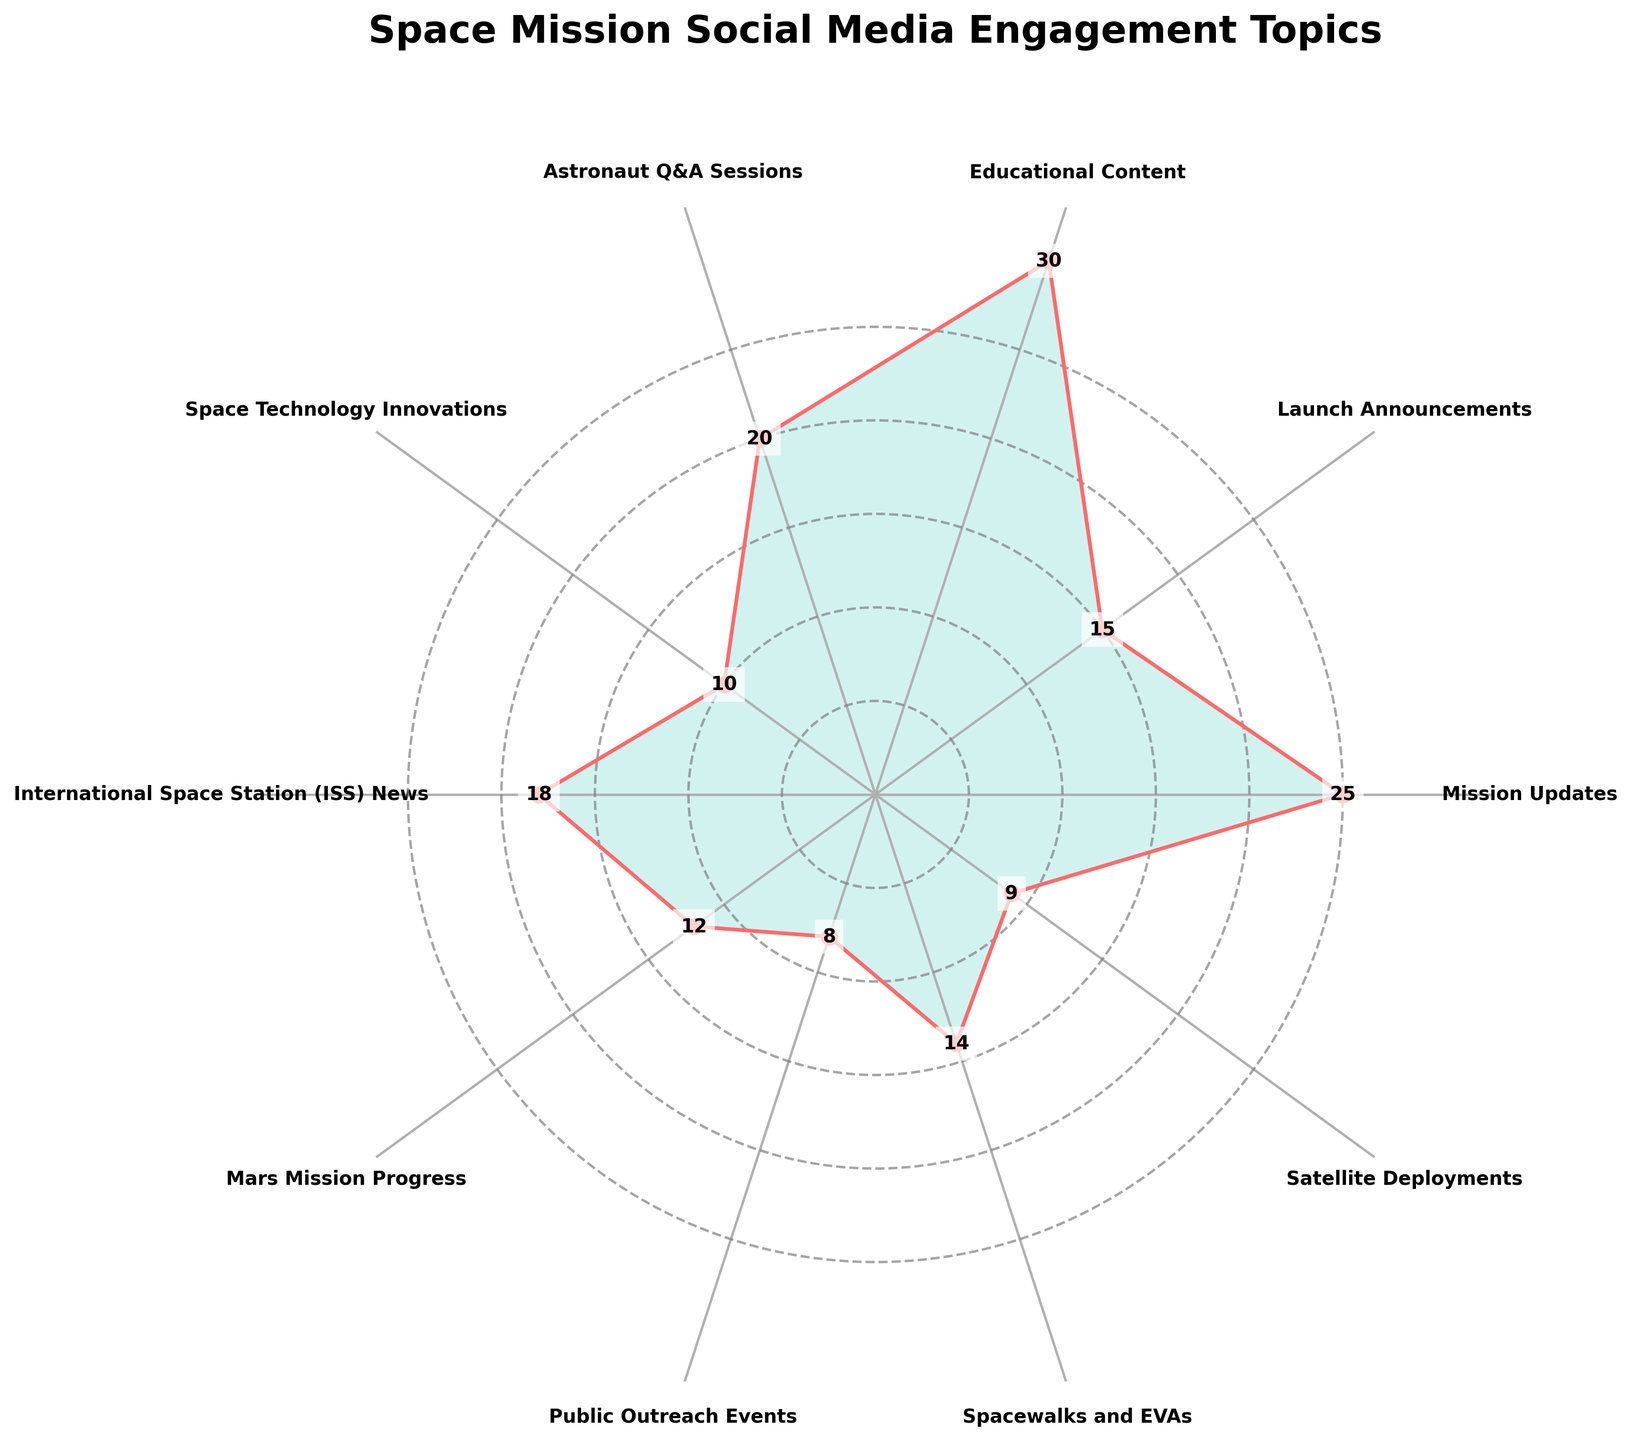Which topic has the highest frequency of social media engagement? By looking at the plot, the topic with the largest value indicated by the highest point on the chart is the one with the highest frequency. This is Educational Content with a frequency of 30.
Answer: Educational Content Which topic has the lowest frequency of social media engagement? Observing the plot, the topic with the smallest value indicated by the lowest point on the chart is the one with the lowest frequency. This is Public Outreach Events with a frequency of 8.
Answer: Public Outreach Events How many topics have a frequency higher than 20? Count the number of topics whose frequencies are positioned above the 20-mark on the radial axis. The topics are Mission Updates (25), Educational Content (30). Therefore, there are 2 topics.
Answer: 2 What is the average frequency of engagement across all topics? Sum all frequencies: 25 + 15 + 30 + 20 + 10 + 18 + 12 + 8 + 14 + 9 = 161. There are 10 topics, so the average frequency is 161 / 10 = 16.1.
Answer: 16.1 Which topic has a frequency closest to 15? Looking at the radial alignments around 15, Launch Announcements with a frequency of 15 is the closest.
Answer: Launch Announcements What is the total frequency for Mission Updates and Spacewalks and EVAs combined? Add the frequencies of the two topics: Mission Updates (25) + Spacewalks and EVAs (14) = 39.
Answer: 39 Which topic has a higher frequency: ISS News or Mars Mission Progress? Compare the frequencies of the two topics from the plot. ISS News has 18 and Mars Mission Progress has 12; therefore, ISS News has higher frequency.
Answer: ISS News How much more frequency does Astronaut Q&A Sessions have compared to Satellite Deployments? Subtract the frequency of Satellite Deployments (9) from the frequency of Astronaut Q&A Sessions (20): 20 - 9 = 11.
Answer: 11 What is the median frequency of engagement topics? Sort the frequencies: 8, 9, 10, 12, 14, 15, 18, 20, 25, 30. The median is the average of the 5th and 6th values: (14 + 15) / 2 = 14.5.
Answer: 14.5 Which topic appears directly opposite to Educational Content in the rose chart layout? Identify the topic positioned directly opposite (180 degrees away) Educational Content in the polar plot. This is Mars Mission Progress.
Answer: Mars Mission Progress 